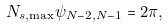<formula> <loc_0><loc_0><loc_500><loc_500>N _ { s , \max } \psi _ { N - 2 , N - 1 } & = 2 \pi ,</formula> 